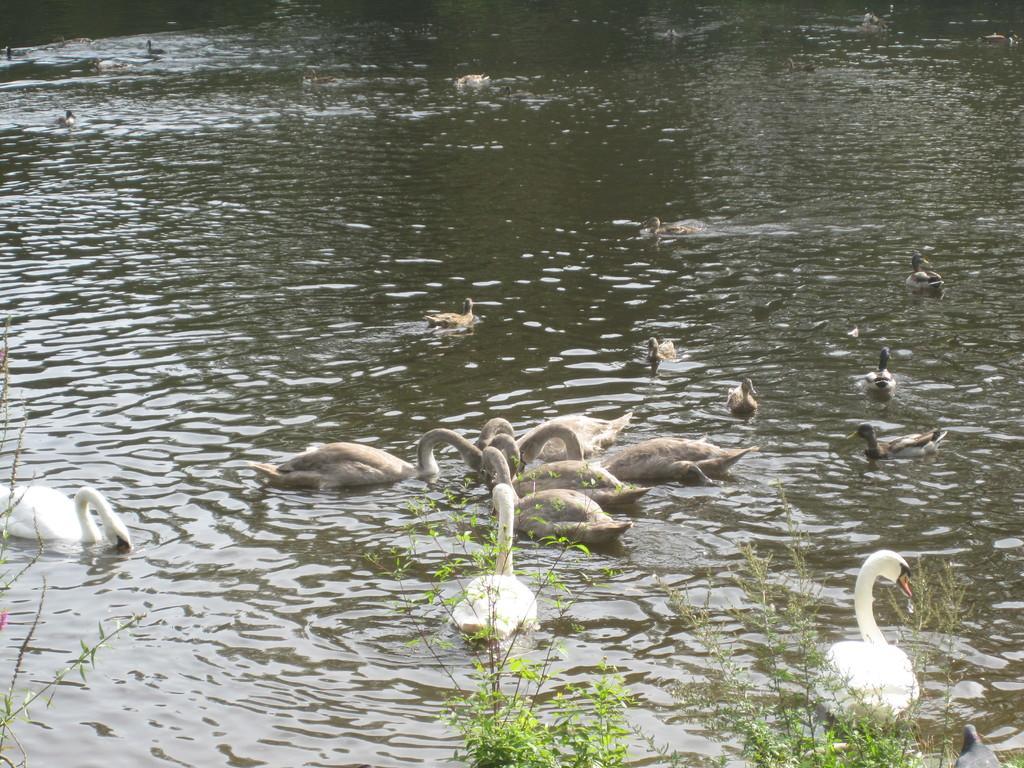Can you describe this image briefly? In this image, I can see the swans and ducks in the water. At the bottom of the image, there are plants. 